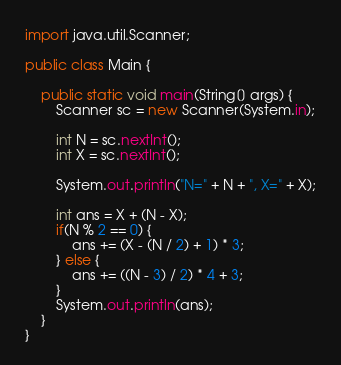Convert code to text. <code><loc_0><loc_0><loc_500><loc_500><_Java_>import java.util.Scanner;

public class Main {

    public static void main(String[] args) {
        Scanner sc = new Scanner(System.in);

        int N = sc.nextInt();
        int X = sc.nextInt();

        System.out.println("N=" + N + ", X=" + X);

        int ans = X + (N - X);
        if(N % 2 == 0) {
            ans += (X - (N / 2) + 1) * 3;
        } else {
            ans += ((N - 3) / 2) * 4 + 3;
        }
        System.out.println(ans);
    }
}</code> 